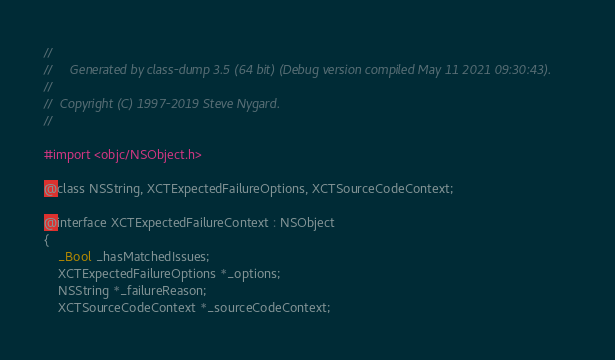Convert code to text. <code><loc_0><loc_0><loc_500><loc_500><_C_>//
//     Generated by class-dump 3.5 (64 bit) (Debug version compiled May 11 2021 09:30:43).
//
//  Copyright (C) 1997-2019 Steve Nygard.
//

#import <objc/NSObject.h>

@class NSString, XCTExpectedFailureOptions, XCTSourceCodeContext;

@interface XCTExpectedFailureContext : NSObject
{
    _Bool _hasMatchedIssues;
    XCTExpectedFailureOptions *_options;
    NSString *_failureReason;
    XCTSourceCodeContext *_sourceCodeContext;</code> 